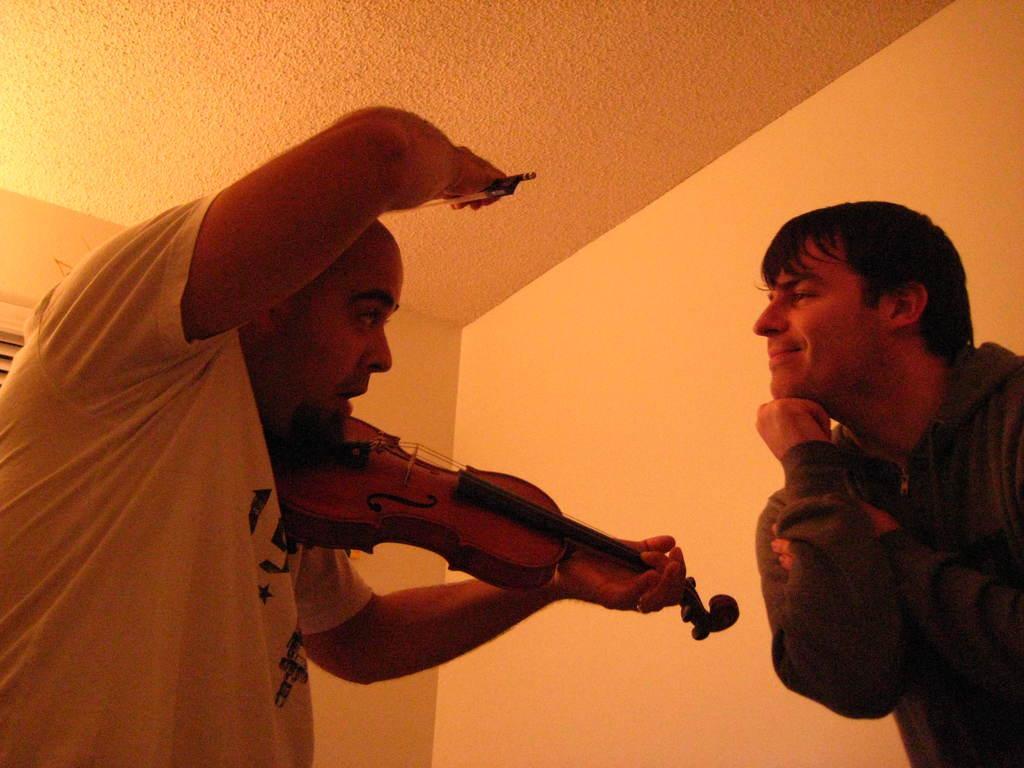Describe this image in one or two sentences. On the left side of the image we can see a person holding a violin in his hands. On the right side of the image we can see a person standing. In the background we can see a wall. 